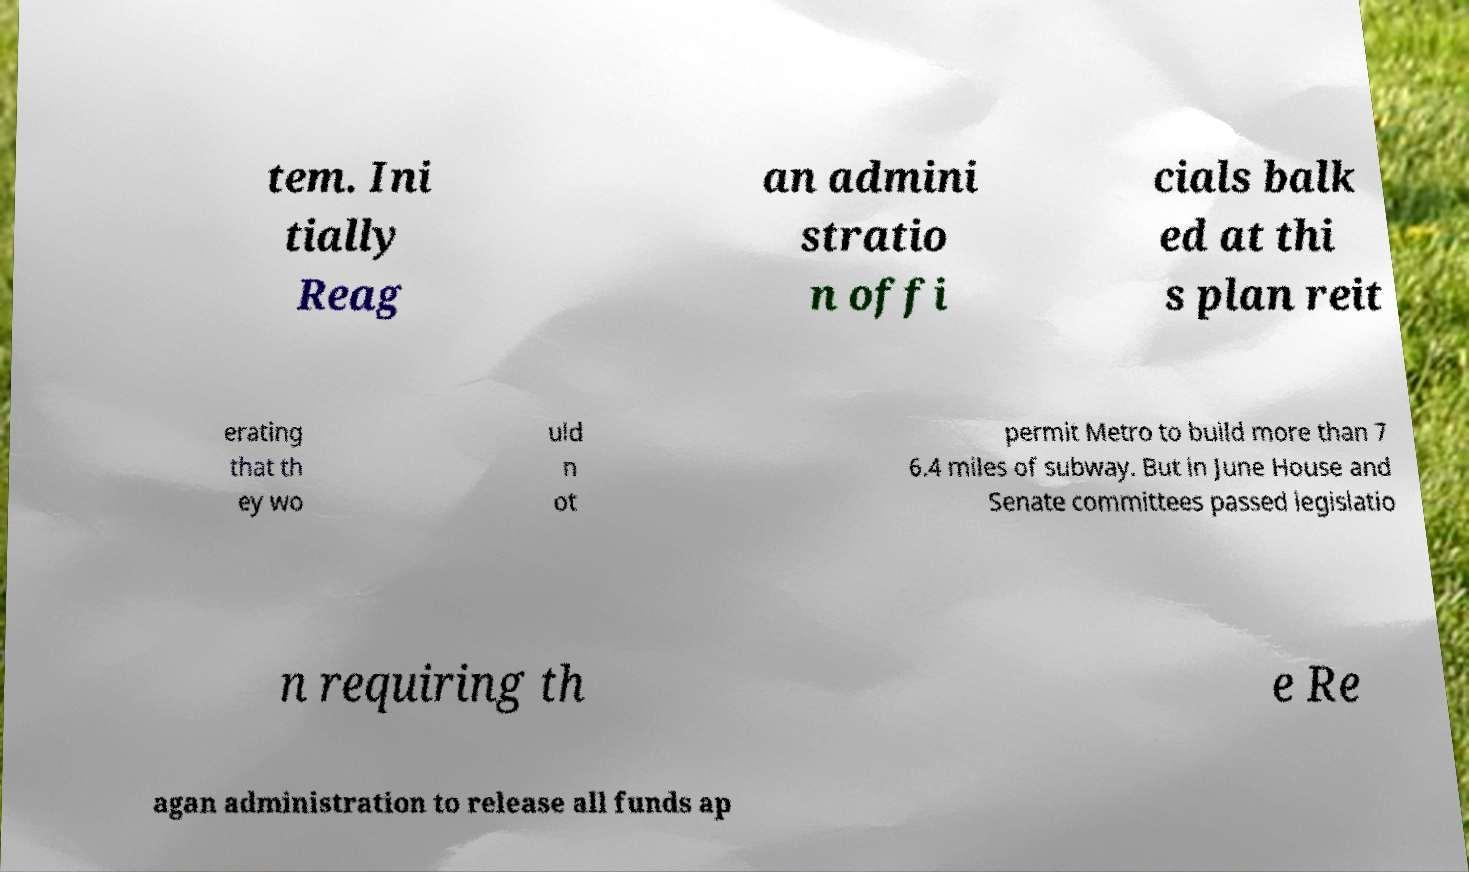Can you read and provide the text displayed in the image?This photo seems to have some interesting text. Can you extract and type it out for me? tem. Ini tially Reag an admini stratio n offi cials balk ed at thi s plan reit erating that th ey wo uld n ot permit Metro to build more than 7 6.4 miles of subway. But in June House and Senate committees passed legislatio n requiring th e Re agan administration to release all funds ap 